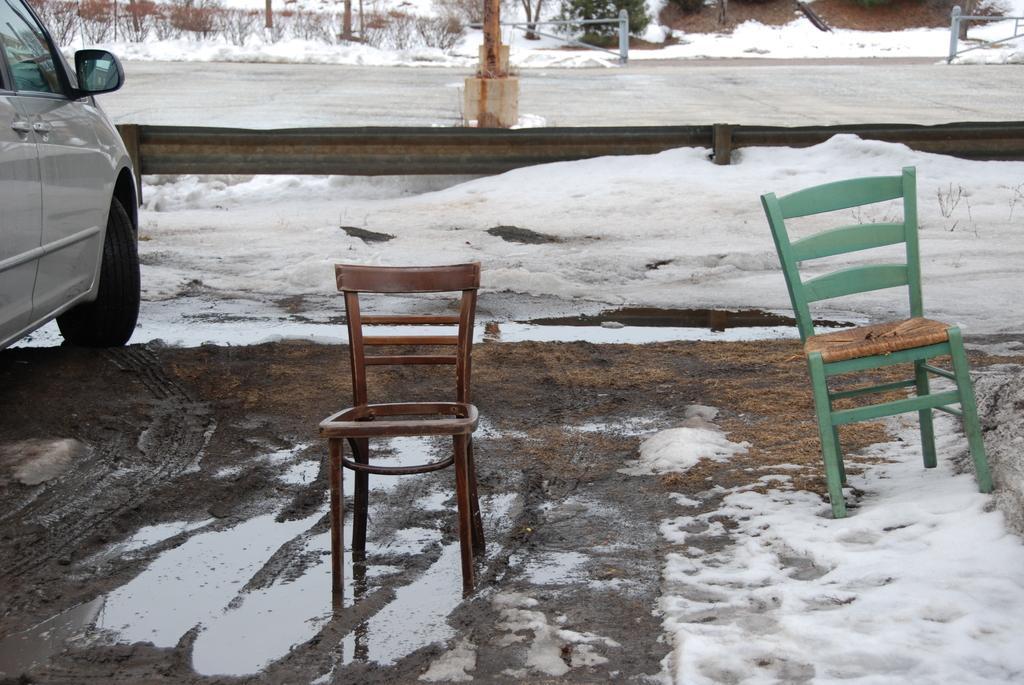Could you give a brief overview of what you see in this image? In this image, in the middle there is a chair which is in brown color, in the right side there is a there is a chair which is in green color, In the left side there is a car which is in white color, there is snow on the ground, in the middle there is a pole which is in yellow color. 